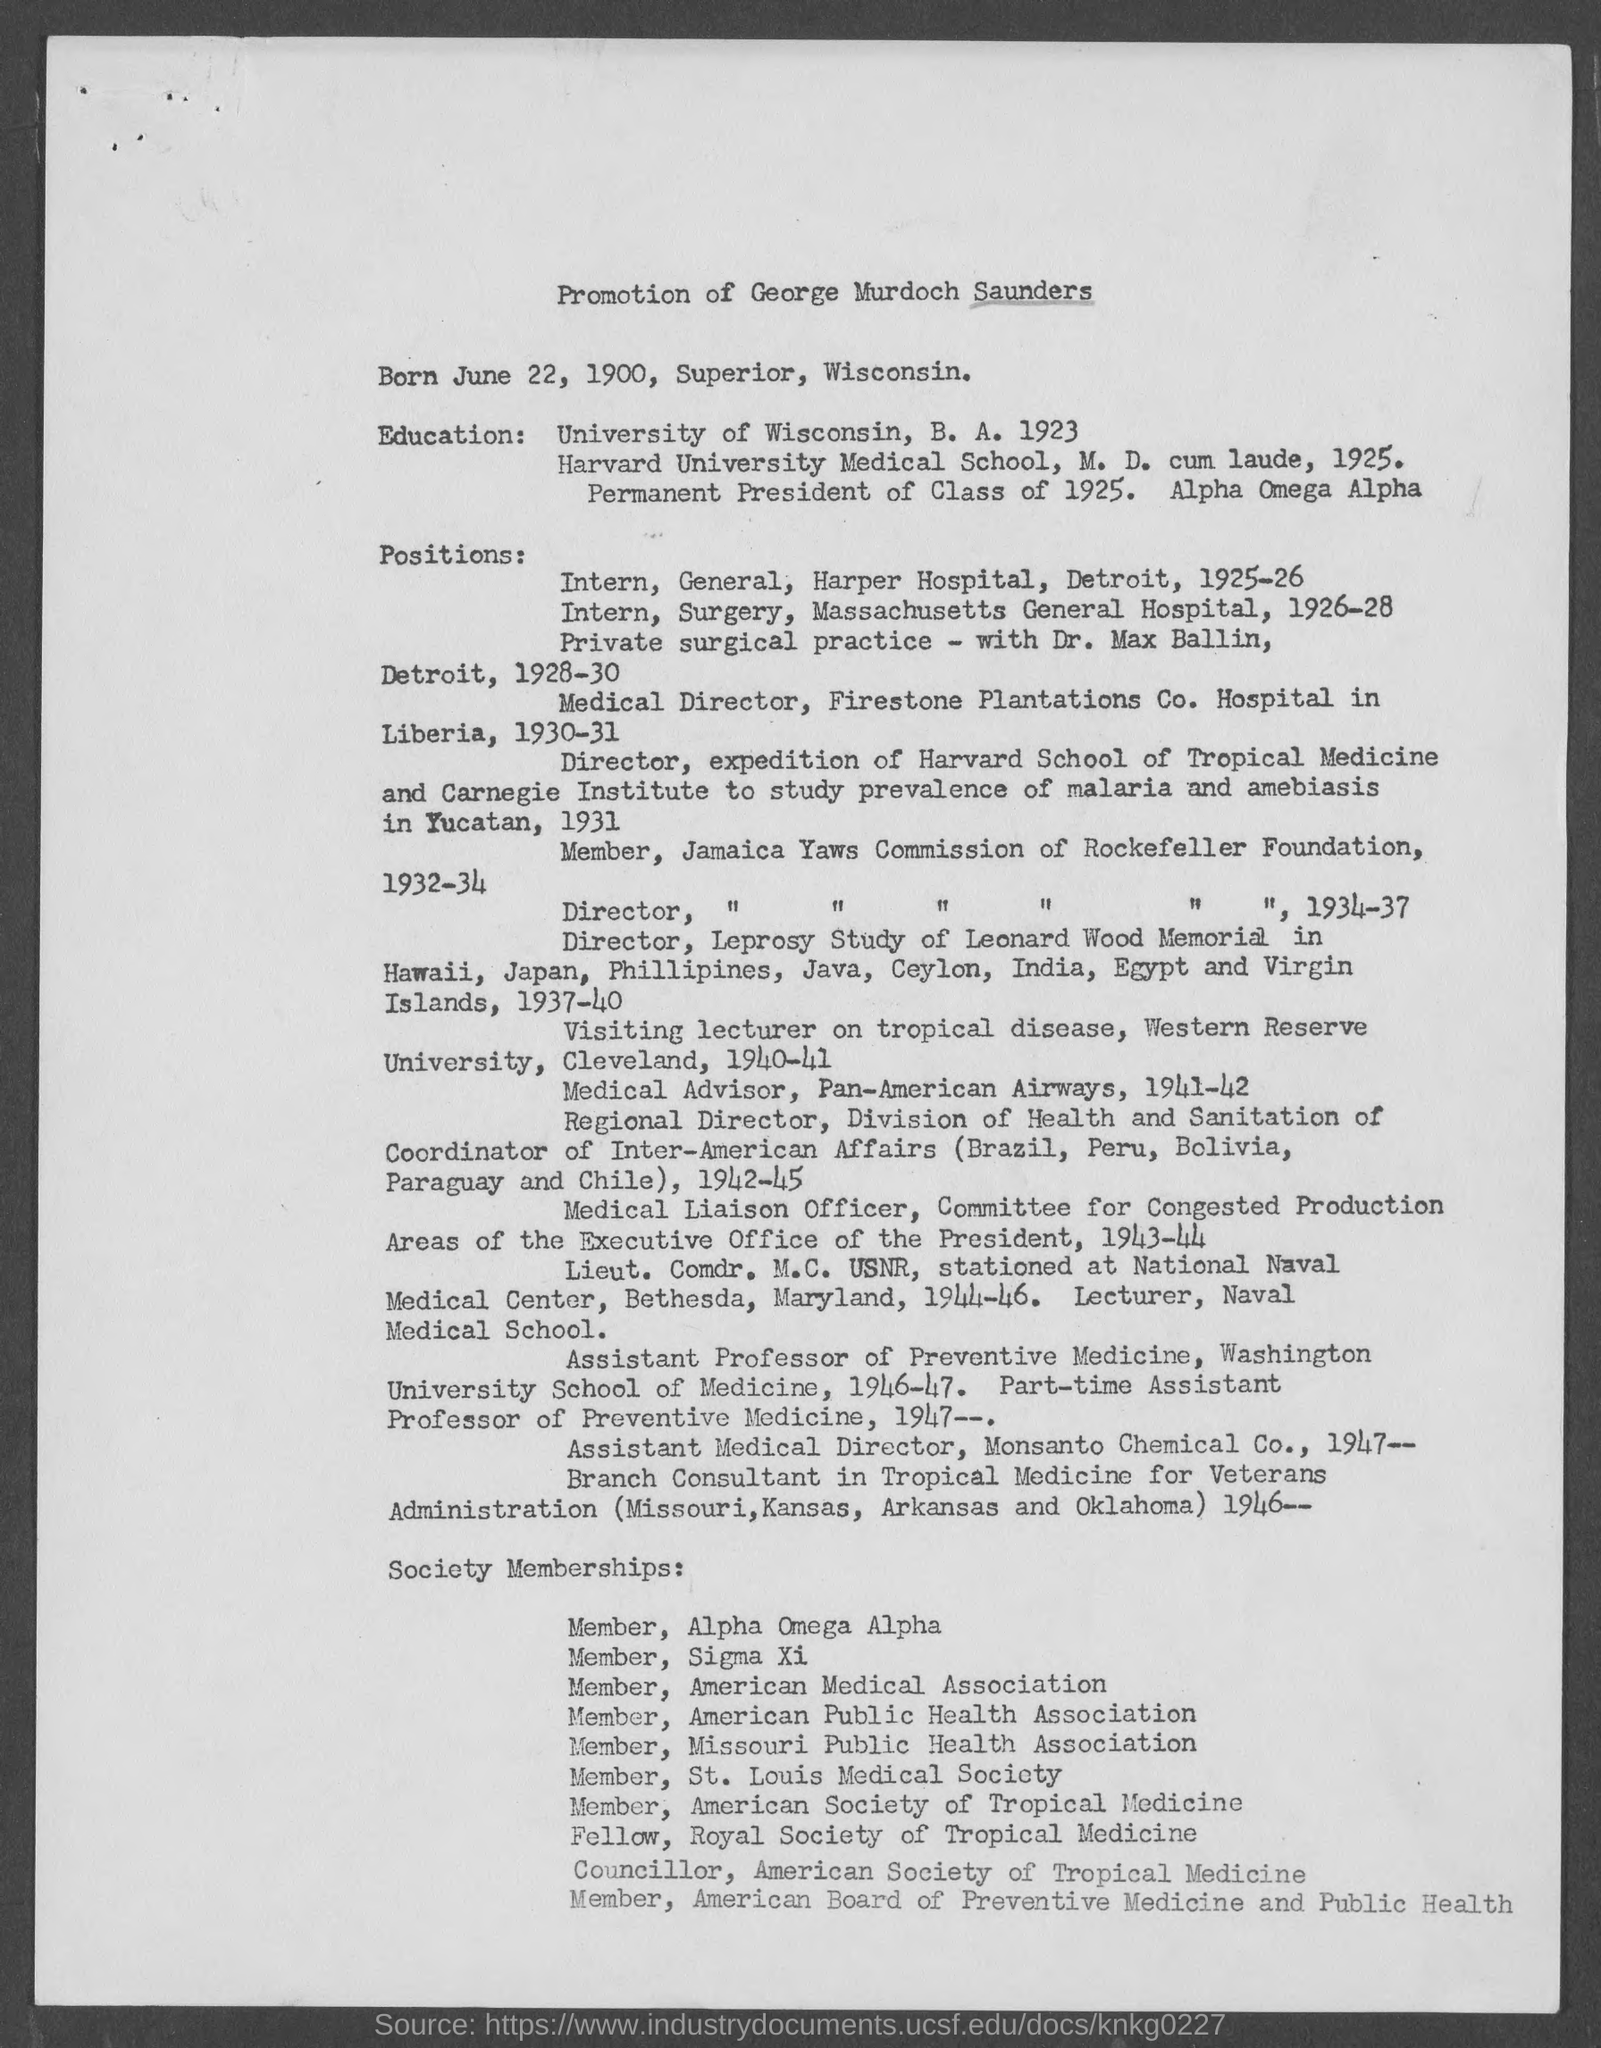Highlight a few significant elements in this photo. The date of birth of George Murdoch Saunders is June 22, 1900. The candidate named George Murdoch Saunders is being considered for promotion. The place of birth of George Murdoch Saunders is Superior, Wisconsin. 